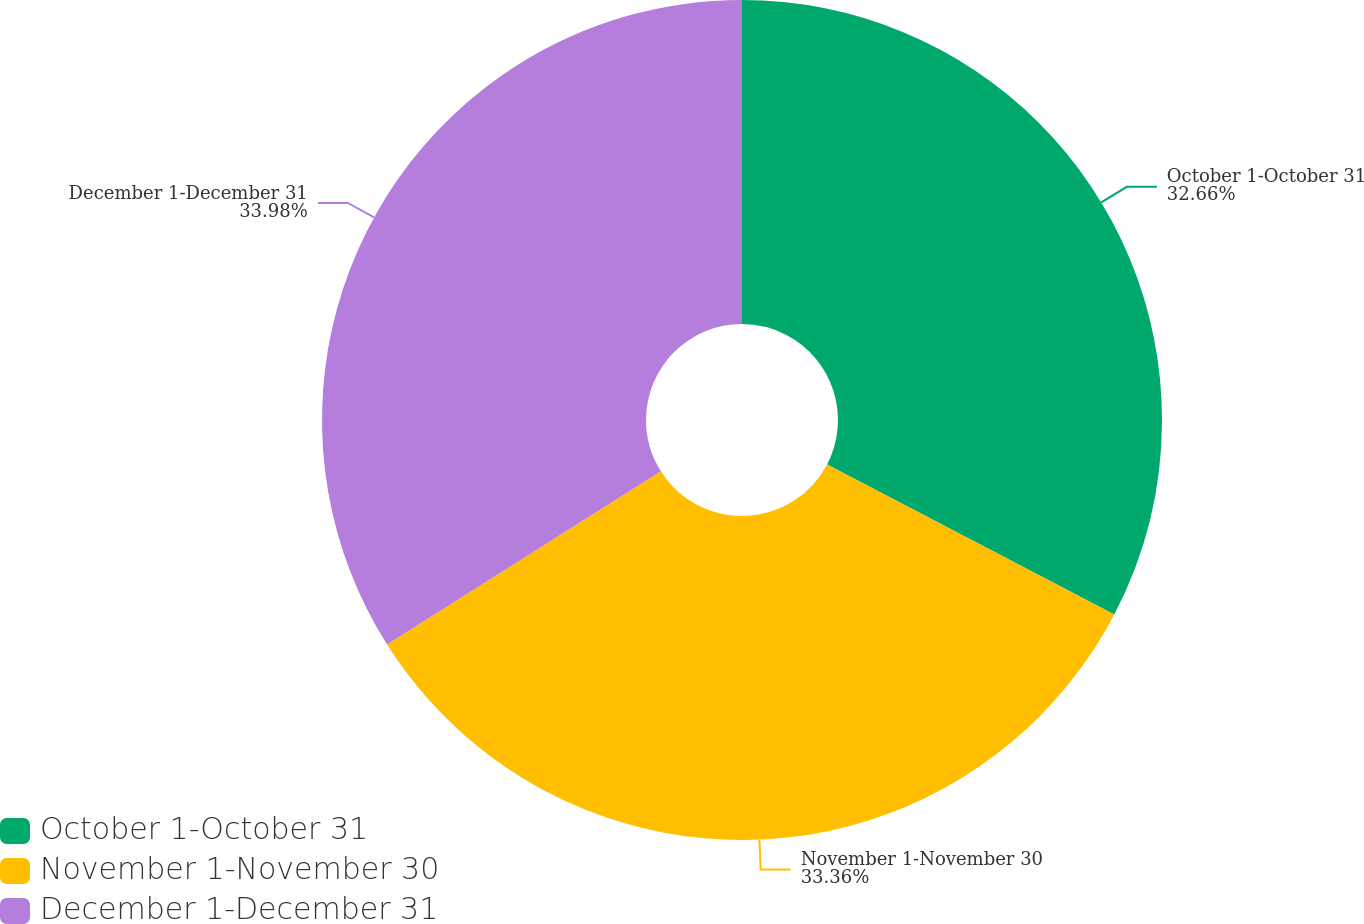Convert chart. <chart><loc_0><loc_0><loc_500><loc_500><pie_chart><fcel>October 1-October 31<fcel>November 1-November 30<fcel>December 1-December 31<nl><fcel>32.66%<fcel>33.36%<fcel>33.98%<nl></chart> 